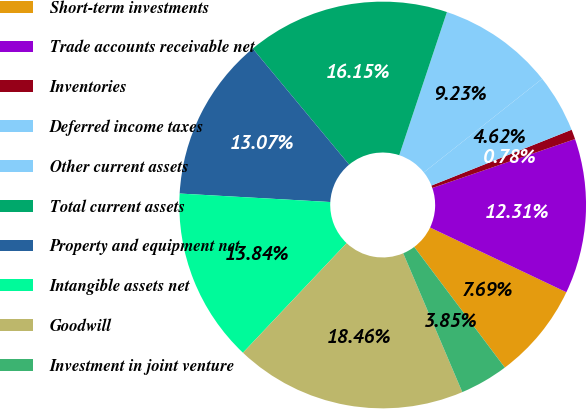<chart> <loc_0><loc_0><loc_500><loc_500><pie_chart><fcel>Short-term investments<fcel>Trade accounts receivable net<fcel>Inventories<fcel>Deferred income taxes<fcel>Other current assets<fcel>Total current assets<fcel>Property and equipment net<fcel>Intangible assets net<fcel>Goodwill<fcel>Investment in joint venture<nl><fcel>7.69%<fcel>12.31%<fcel>0.78%<fcel>4.62%<fcel>9.23%<fcel>16.15%<fcel>13.07%<fcel>13.84%<fcel>18.46%<fcel>3.85%<nl></chart> 